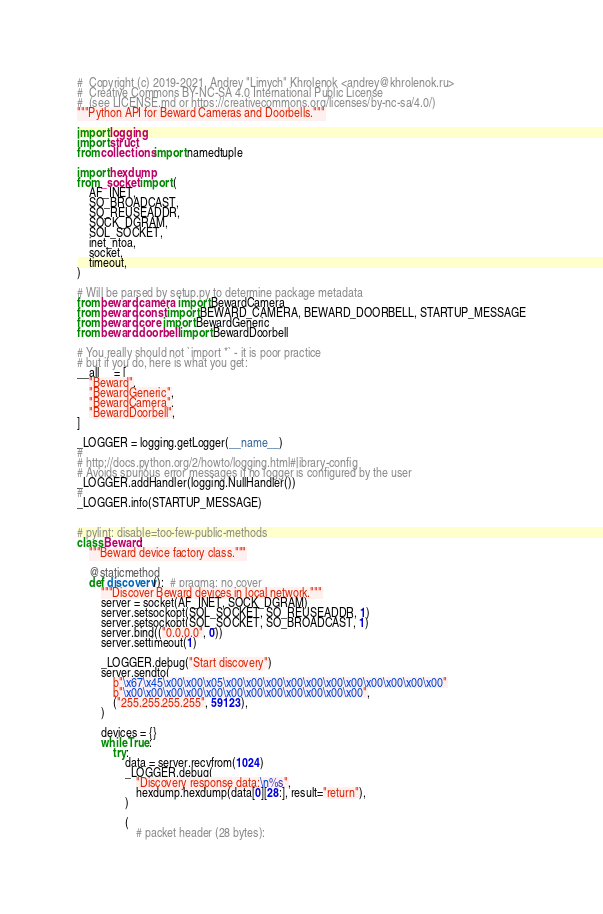<code> <loc_0><loc_0><loc_500><loc_500><_Python_>#  Copyright (c) 2019-2021, Andrey "Limych" Khrolenok <andrey@khrolenok.ru>
#  Creative Commons BY-NC-SA 4.0 International Public License
#  (see LICENSE.md or https://creativecommons.org/licenses/by-nc-sa/4.0/)
"""Python API for Beward Cameras and Doorbells."""

import logging
import struct
from collections import namedtuple

import hexdump
from _socket import (
    AF_INET,
    SO_BROADCAST,
    SO_REUSEADDR,
    SOCK_DGRAM,
    SOL_SOCKET,
    inet_ntoa,
    socket,
    timeout,
)

# Will be parsed by setup.py to determine package metadata
from beward.camera import BewardCamera
from beward.const import BEWARD_CAMERA, BEWARD_DOORBELL, STARTUP_MESSAGE
from beward.core import BewardGeneric
from beward.doorbell import BewardDoorbell

# You really should not `import *` - it is poor practice
# but if you do, here is what you get:
__all__ = [
    "Beward",
    "BewardGeneric",
    "BewardCamera",
    "BewardDoorbell",
]

_LOGGER = logging.getLogger(__name__)
#
# http://docs.python.org/2/howto/logging.html#library-config
# Avoids spurious error messages if no logger is configured by the user
_LOGGER.addHandler(logging.NullHandler())
#
_LOGGER.info(STARTUP_MESSAGE)


# pylint: disable=too-few-public-methods
class Beward:
    """Beward device factory class."""

    @staticmethod
    def discovery():  # pragma: no cover
        """Discover Beward devices in local network."""
        server = socket(AF_INET, SOCK_DGRAM)
        server.setsockopt(SOL_SOCKET, SO_REUSEADDR, 1)
        server.setsockopt(SOL_SOCKET, SO_BROADCAST, 1)
        server.bind(("0.0.0.0", 0))
        server.settimeout(1)

        _LOGGER.debug("Start discovery")
        server.sendto(
            b"\x67\x45\x00\x00\x05\x00\x00\x00\x00\x00\x00\x00\x00\x00\x00\x00"
            b"\x00\x00\x00\x00\x00\x00\x00\x00\x00\x00\x00\x00",
            ("255.255.255.255", 59123),
        )

        devices = {}
        while True:
            try:
                data = server.recvfrom(1024)
                _LOGGER.debug(
                    "Discovery response data:\n%s",
                    hexdump.hexdump(data[0][28:], result="return"),
                )

                (
                    # packet header (28 bytes):</code> 